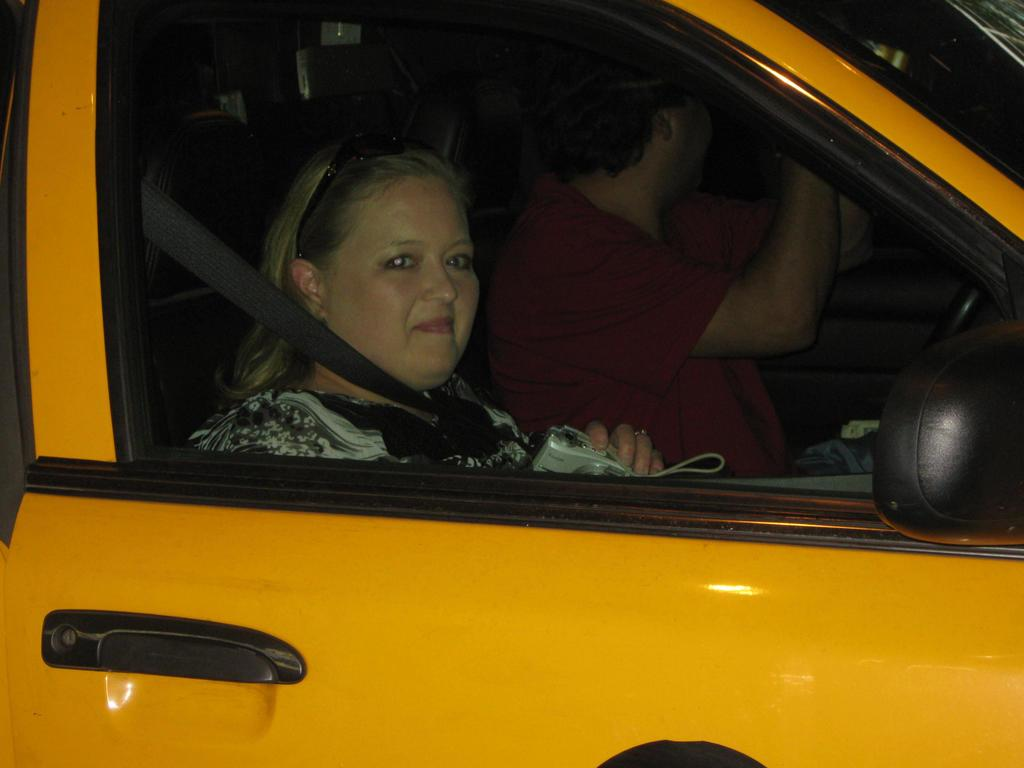What is the main subject of the image? The main subject of the image is a car. Can you describe the car's appearance? The car is yellow. Are there any people inside the car? Yes, there are two persons sitting inside the car. Can you tell me how many dinosaurs are visible in the image? There are no dinosaurs present in the image; it features a yellow car with two persons inside. What type of snails can be seen crawling on the car's windshield in the image? There are no snails visible on the car's windshield in the image. 